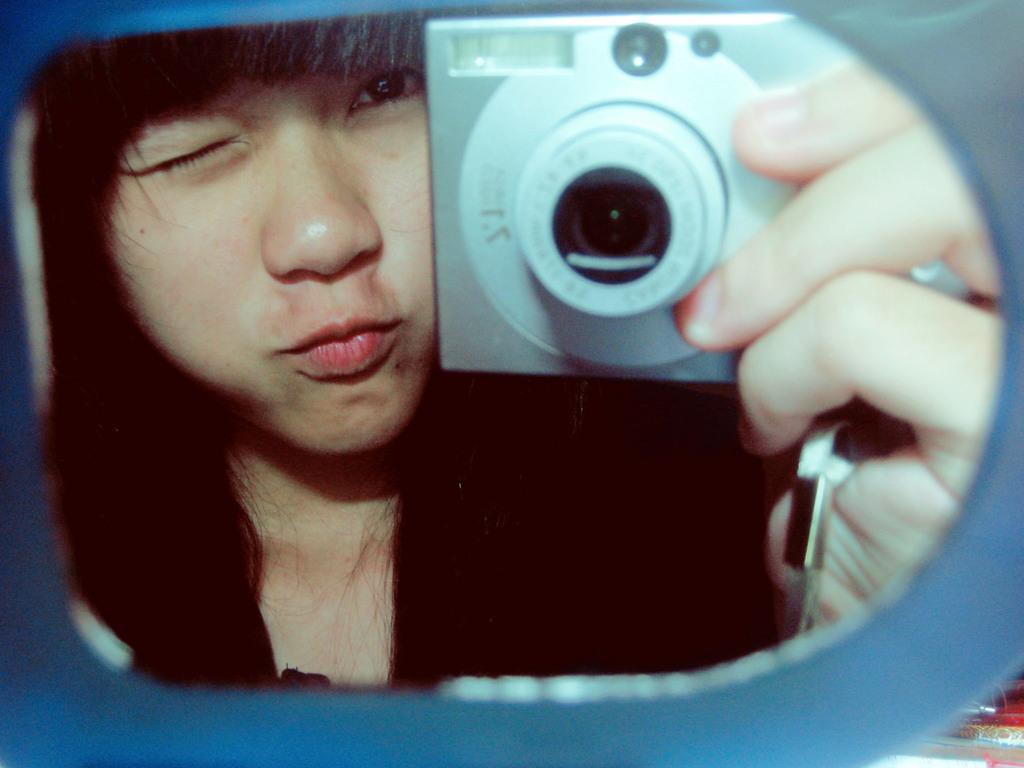Describe this image in one or two sentences. In this image I can see the person holding the camera. 